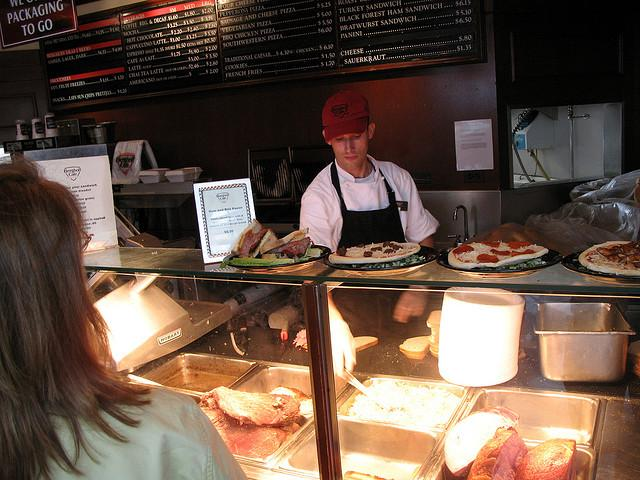What type of meat is most visible near the front of the glass?

Choices:
A) red meat
B) chicken
C) fake
D) fish red meat 